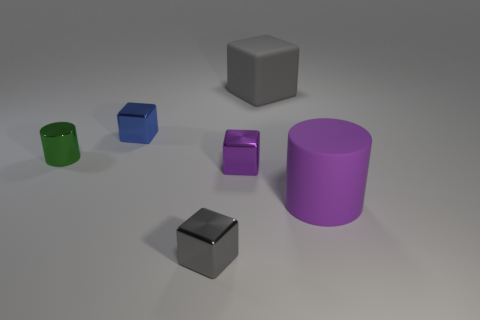Can you describe the texture and color of the object that is the tallest in the image? The tallest object in the image is a purple cylindrical shape with a smooth, matte surface. Its color is a solid, vibrant shade of purple. 